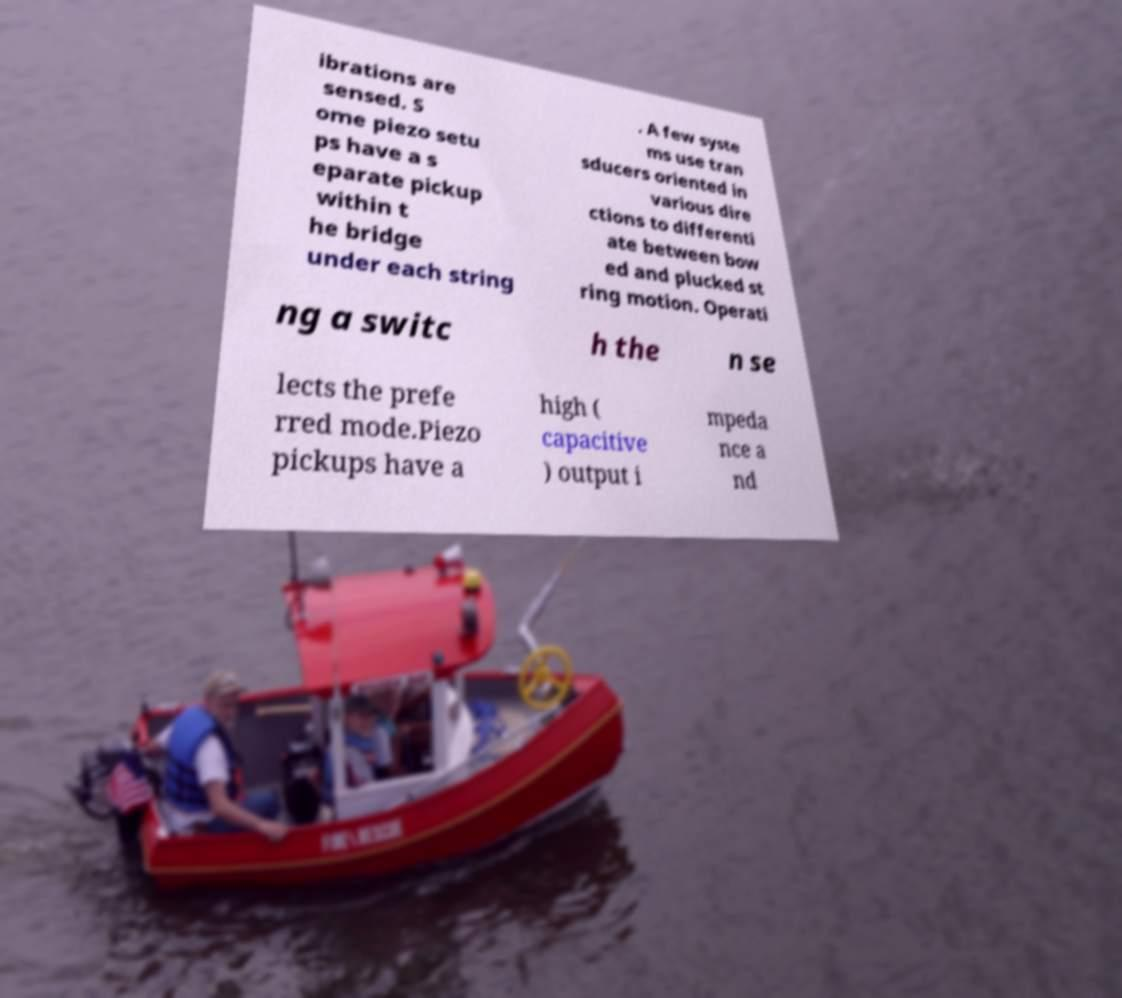Could you extract and type out the text from this image? ibrations are sensed. S ome piezo setu ps have a s eparate pickup within t he bridge under each string . A few syste ms use tran sducers oriented in various dire ctions to differenti ate between bow ed and plucked st ring motion. Operati ng a switc h the n se lects the prefe rred mode.Piezo pickups have a high ( capacitive ) output i mpeda nce a nd 